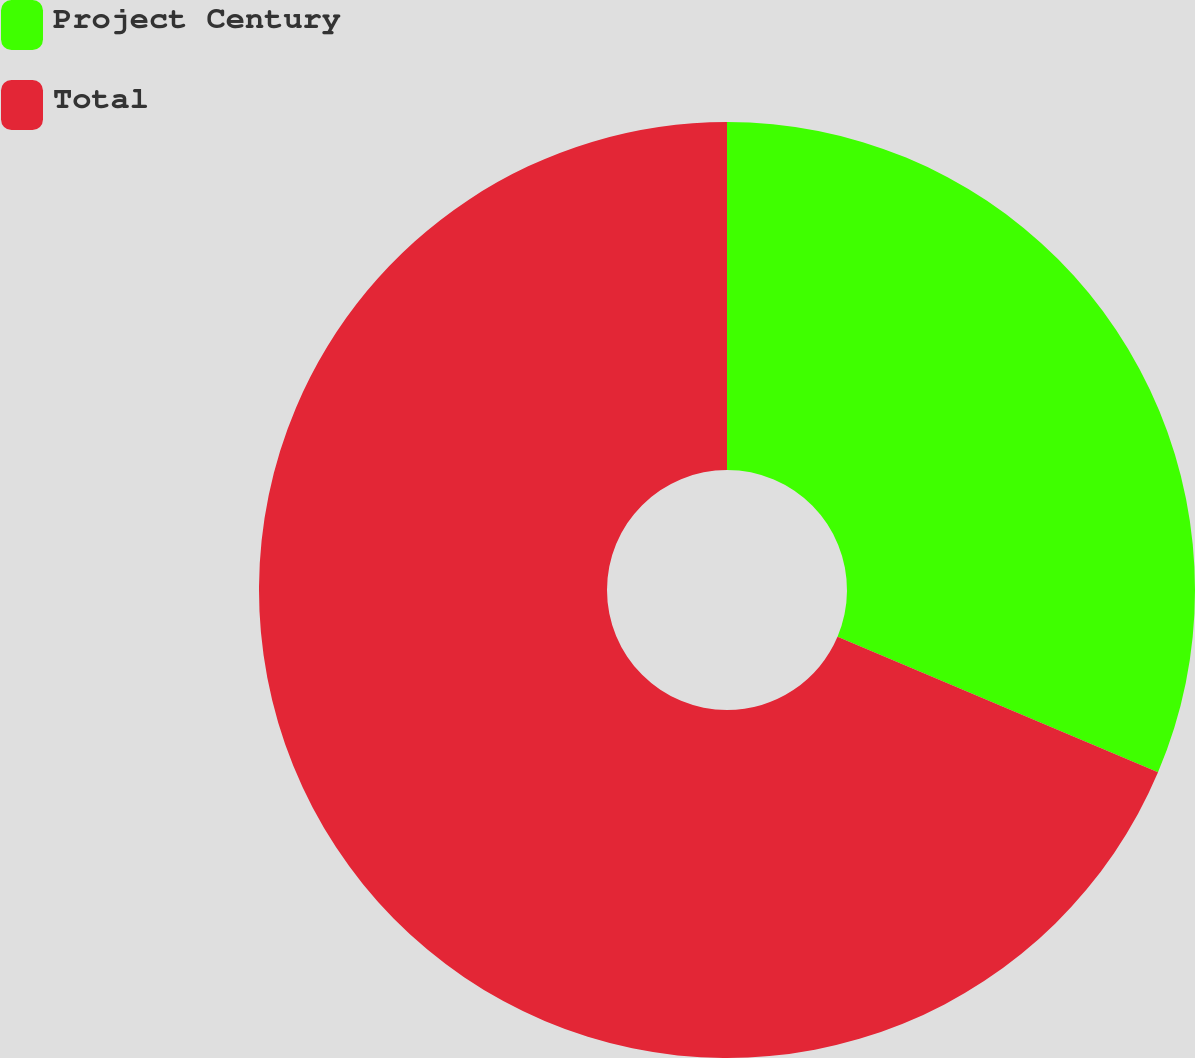Convert chart to OTSL. <chart><loc_0><loc_0><loc_500><loc_500><pie_chart><fcel>Project Century<fcel>Total<nl><fcel>31.37%<fcel>68.63%<nl></chart> 